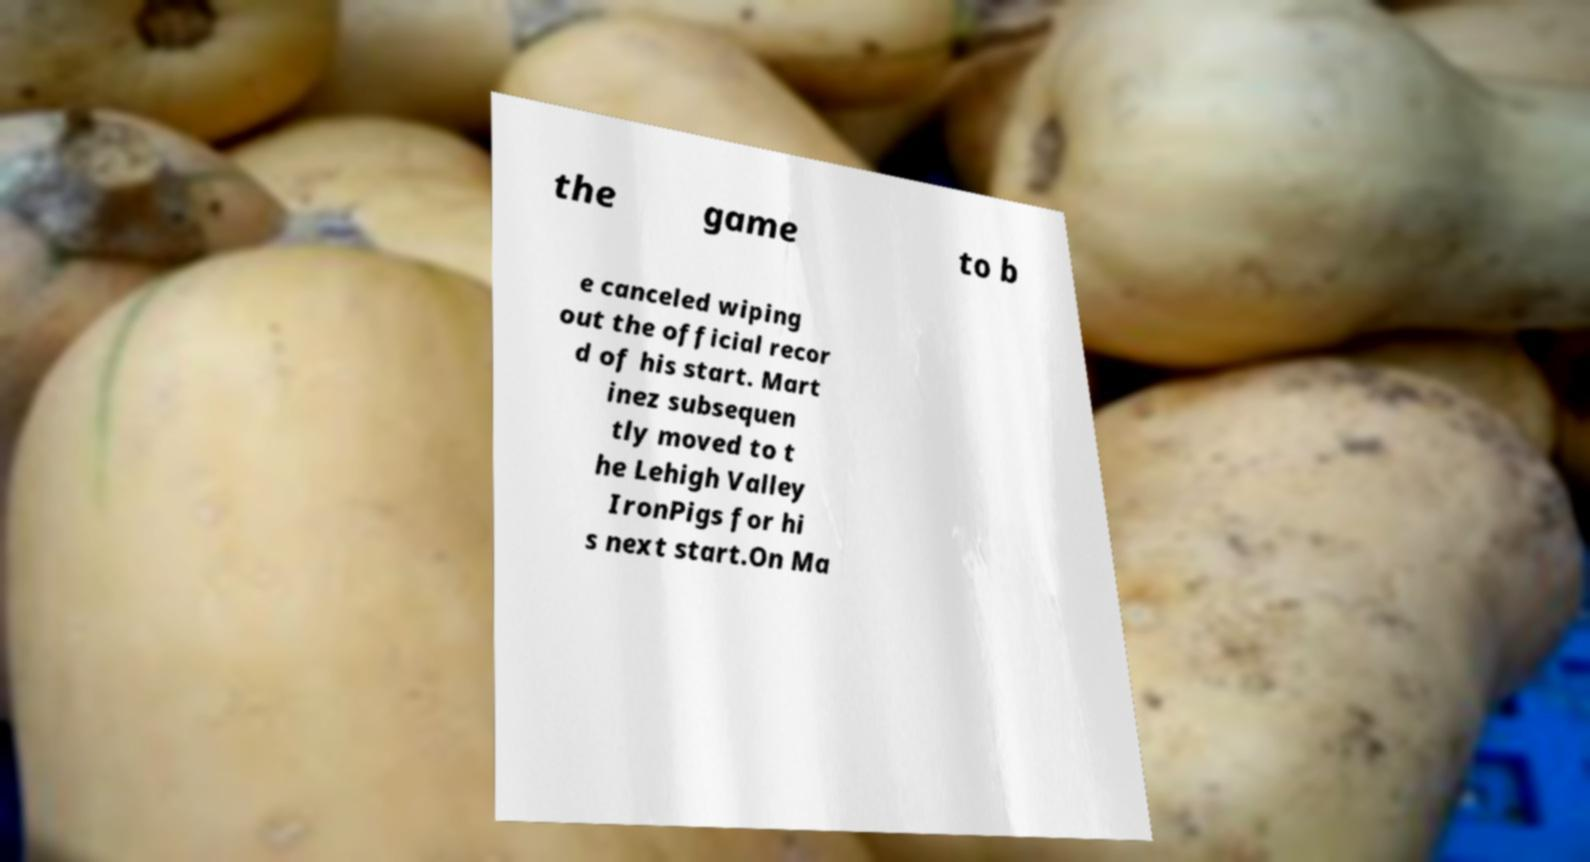What messages or text are displayed in this image? I need them in a readable, typed format. the game to b e canceled wiping out the official recor d of his start. Mart inez subsequen tly moved to t he Lehigh Valley IronPigs for hi s next start.On Ma 